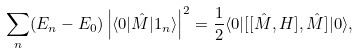<formula> <loc_0><loc_0><loc_500><loc_500>\sum _ { n } ( E _ { n } - E _ { 0 } ) \left | \langle 0 | \hat { M } | 1 _ { n } \rangle \right | ^ { 2 } = \frac { 1 } { 2 } \langle 0 | [ [ \hat { M } , H ] , \hat { M } ] | 0 \rangle ,</formula> 